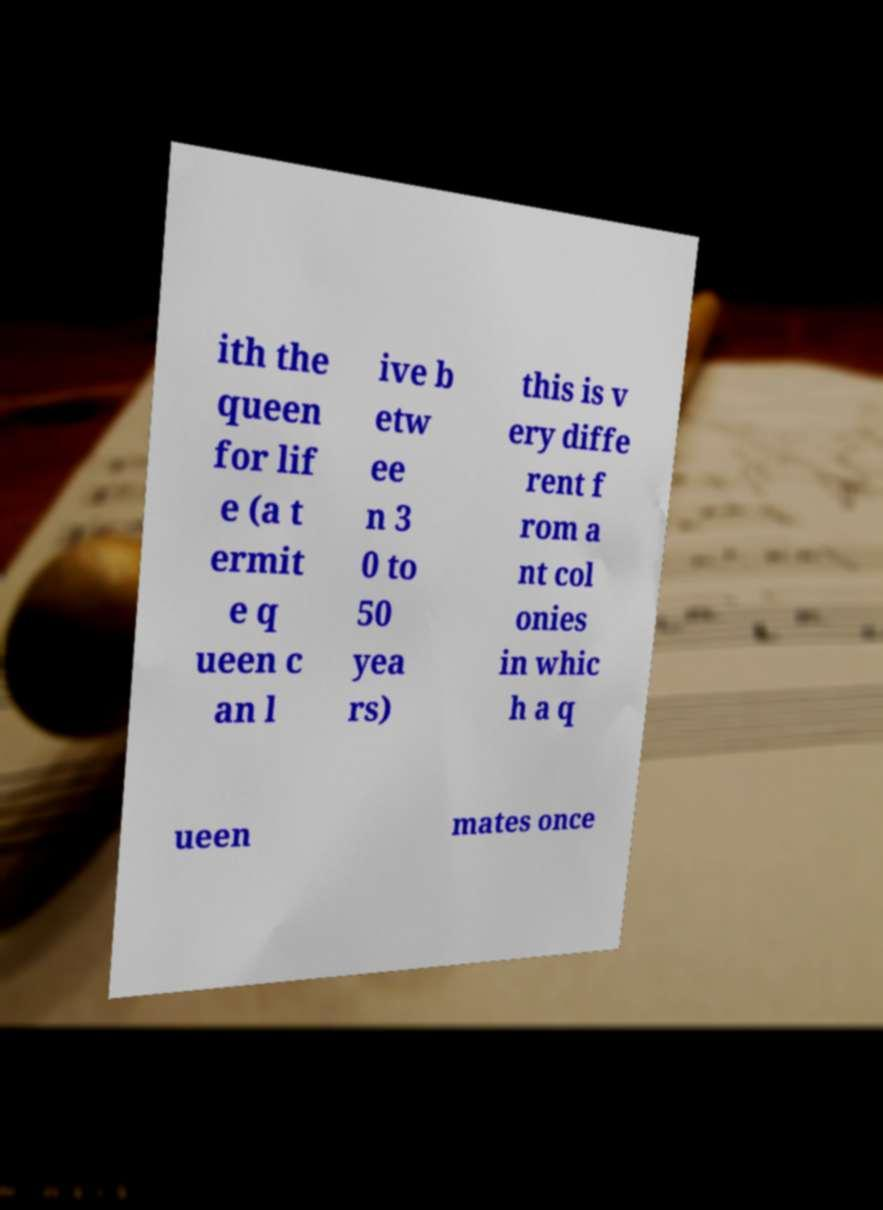Please read and relay the text visible in this image. What does it say? ith the queen for lif e (a t ermit e q ueen c an l ive b etw ee n 3 0 to 50 yea rs) this is v ery diffe rent f rom a nt col onies in whic h a q ueen mates once 